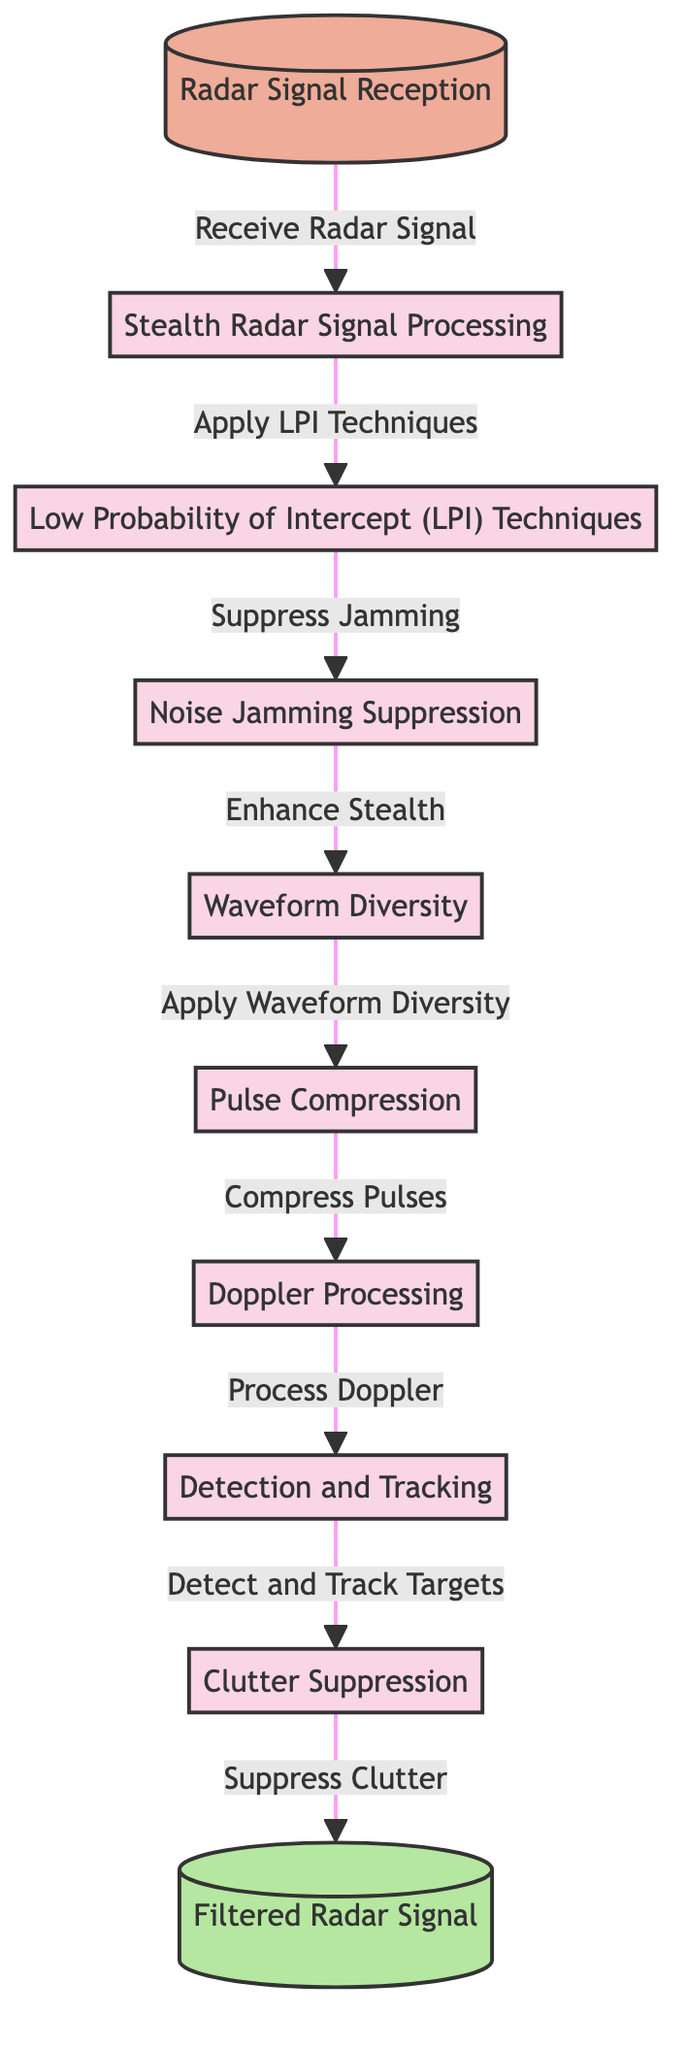What is the first step in the radar signal processing? The first step, indicated by the node labeled “Radar Signal Reception,” shows that the initial action is to receive the radar signal.
Answer: Radar Signal Reception How many main processing techniques are used in the diagram? By counting the distinct processing techniques listed in the nodes, we identify five main techniques: Low Probability of Intercept techniques, Noise Jamming Suppression, Waveform Diversity, Pulse Compression, and Doppler Processing.
Answer: Five What is the output of the radar signal processing? The output node is labeled as “Filtered Radar Signal,” indicating that this is the final processed result of the system.
Answer: Filtered Radar Signal Which processing technique follows Noise Jamming Suppression? The diagram shows that after “Noise Jamming Suppression,” the next step is “Waveform Diversity,” as indicated by the directional flow of arrows.
Answer: Waveform Diversity What is the relationship between the "Detection and Tracking" and "Clutter Suppression"? The relationship is sequential; "Detection and Tracking" is a process that occurs before "Clutter Suppression," indicating that detection must occur before clutter can be suppressed.
Answer: Sequential process What technique is applied after Pulse Compression? According to the diagram, after the “Pulse Compression” step, the technique that is applied next is “Doppler Processing,” as shown by the connections between the nodes.
Answer: Doppler Processing What is the function of Low Probability of Intercept techniques? The diagram shows that Low Probability of Intercept techniques aim to suppress jamming, indicating their primary function in enhancing signal security.
Answer: Suppress jamming How does noise jamming suppression enhance stealth? The flow in the diagram indicates that Noise Jamming Suppression enhances stealth by leading to the application of Waveform Diversity, meaning less detectable signals improve stealth capabilities.
Answer: Apply Waveform Diversity What would the final output node signify in the context of radar operations? The final output node “Filtered Radar Signal” signifies that the processing culminates in a refined signal, which is essential for successful radar operations to track and identify targets effectively.
Answer: Refined signal 